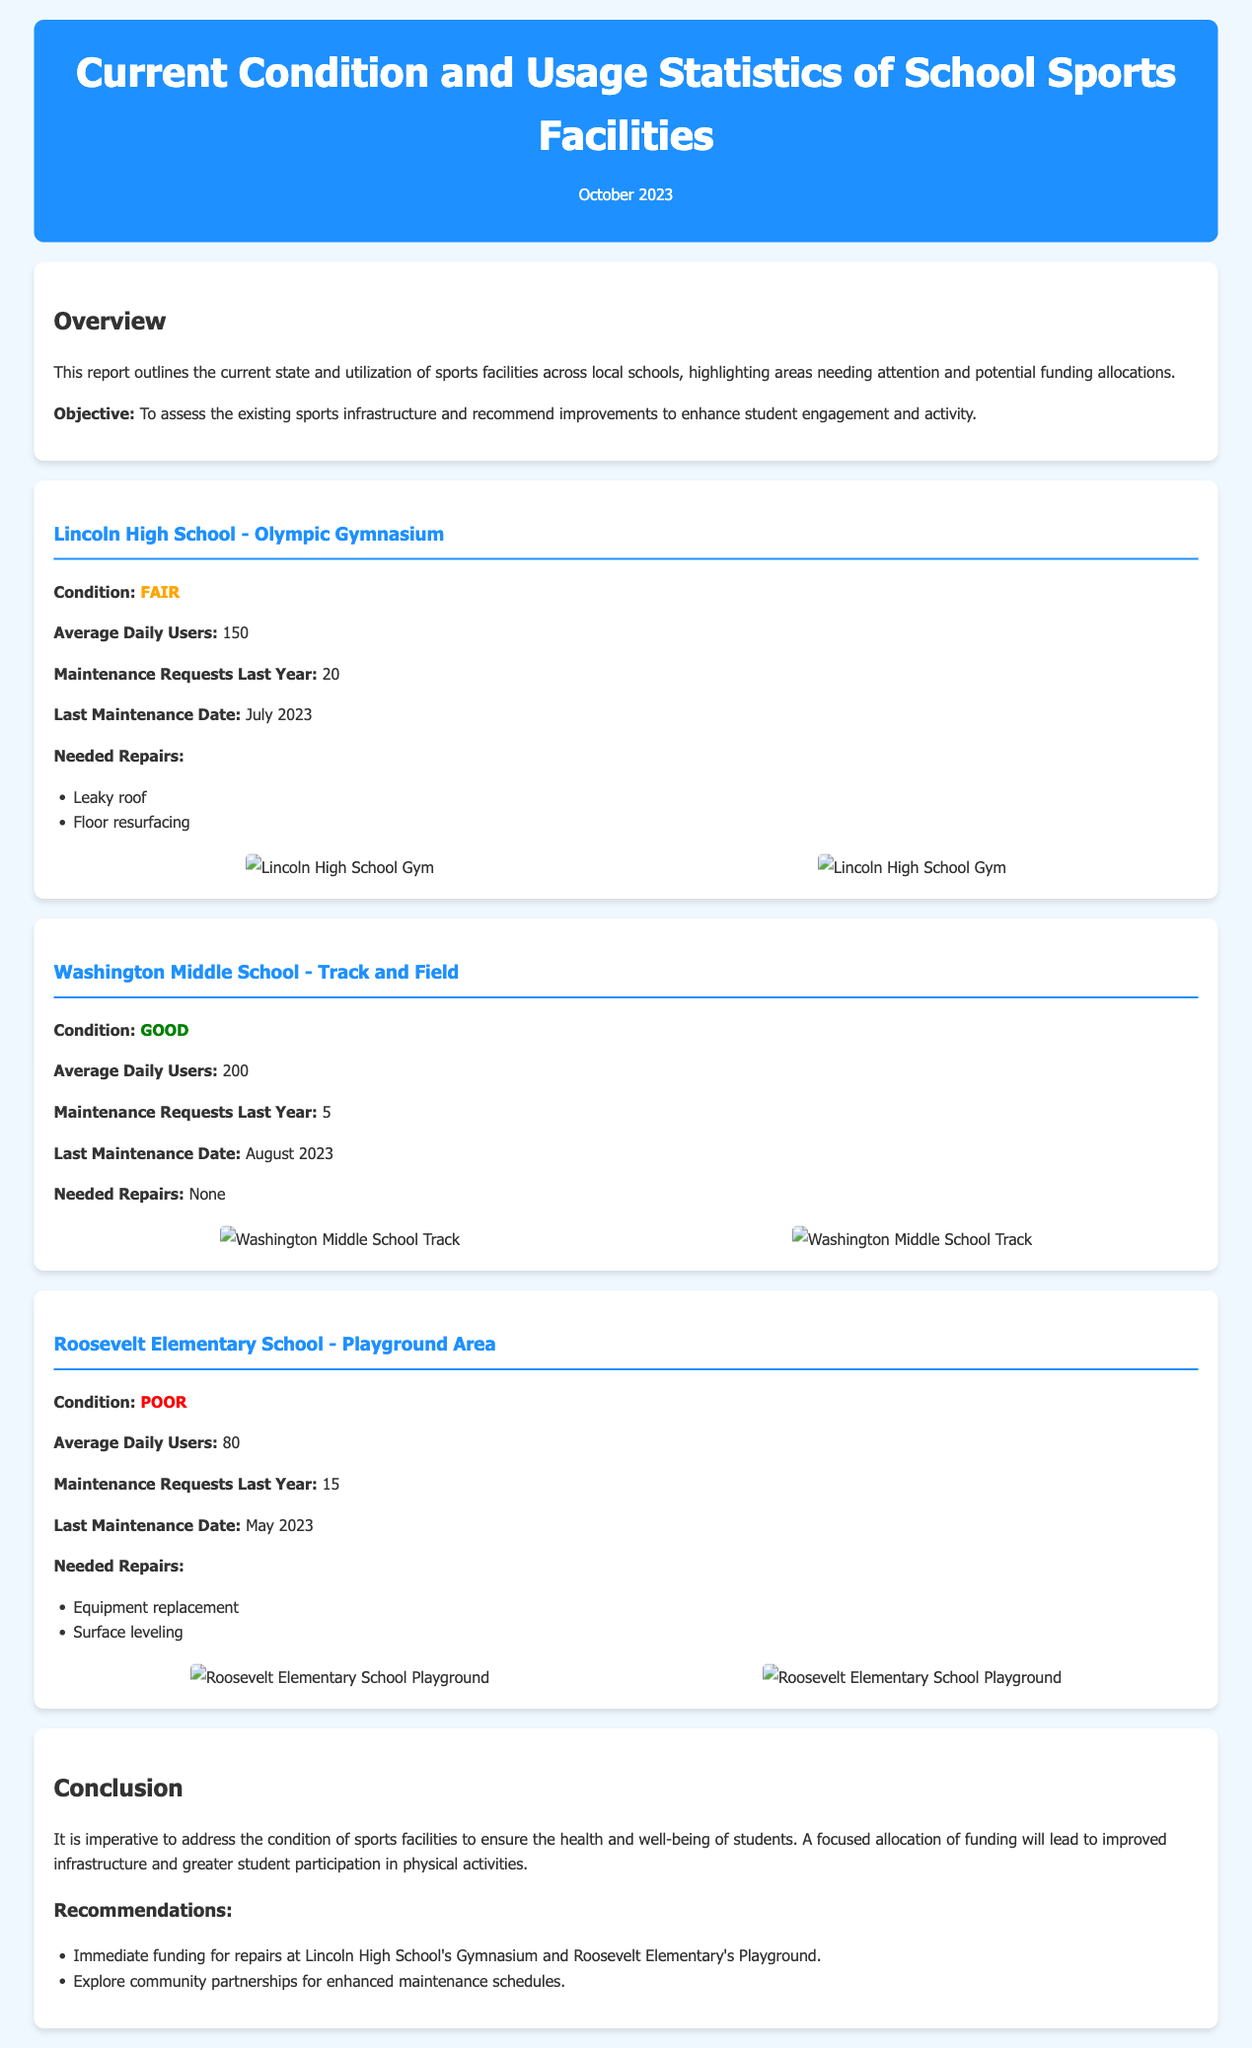What is the condition of Lincoln High School's Olympic Gymnasium? The condition of Lincoln High School's Olympic Gymnasium is stated as "Fair" in the report.
Answer: Fair How many average daily users does Washington Middle School's Track and Field have? The report specifies that Washington Middle School's Track and Field has an average of 200 daily users.
Answer: 200 What are the needed repairs for Roosevelt Elementary School's Playground Area? The needed repairs listed for Roosevelt Elementary School's Playground Area are equipment replacement and surface leveling.
Answer: Equipment replacement, surface leveling When was the last maintenance performed on the facilities at Lincoln High School? The report indicates that the last maintenance date for Lincoln High School's Gymnasium was July 2023.
Answer: July 2023 What is the overall condition status of Roosevelt Elementary School's Playground Area? The condition status of Roosevelt Elementary School's Playground Area is reported as "Poor."
Answer: Poor How many maintenance requests did Washington Middle School receive last year? According to the report, Washington Middle School had 5 maintenance requests last year.
Answer: 5 Which school requires immediate funding for repairs according to the recommendations? The recommendations highlight that immediate funding is needed for repairs at Lincoln High School's Gymnasium and Roosevelt Elementary's Playground.
Answer: Lincoln High School's Gymnasium, Roosevelt Elementary's Playground What is the purpose of this report? The objective of the report is to assess the existing sports infrastructure and recommend improvements.
Answer: Assess existing sports infrastructure and recommend improvements What is highlighted as a consequence of not addressing the condition of sports facilities? The report concludes that failure to address the condition could impact the health and well-being of students.
Answer: Impact health and well-being of students 